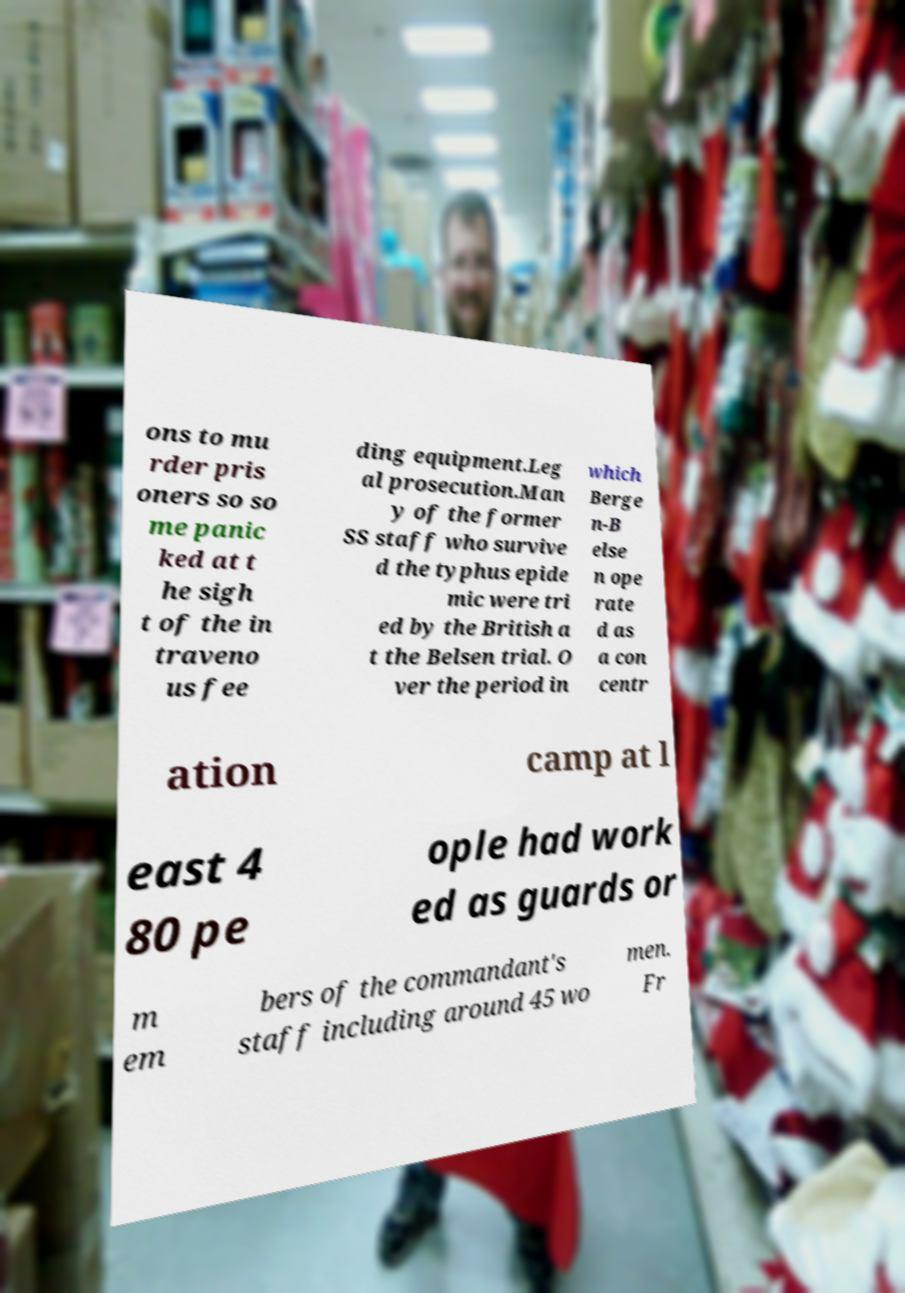What messages or text are displayed in this image? I need them in a readable, typed format. ons to mu rder pris oners so so me panic ked at t he sigh t of the in traveno us fee ding equipment.Leg al prosecution.Man y of the former SS staff who survive d the typhus epide mic were tri ed by the British a t the Belsen trial. O ver the period in which Berge n-B else n ope rate d as a con centr ation camp at l east 4 80 pe ople had work ed as guards or m em bers of the commandant's staff including around 45 wo men. Fr 